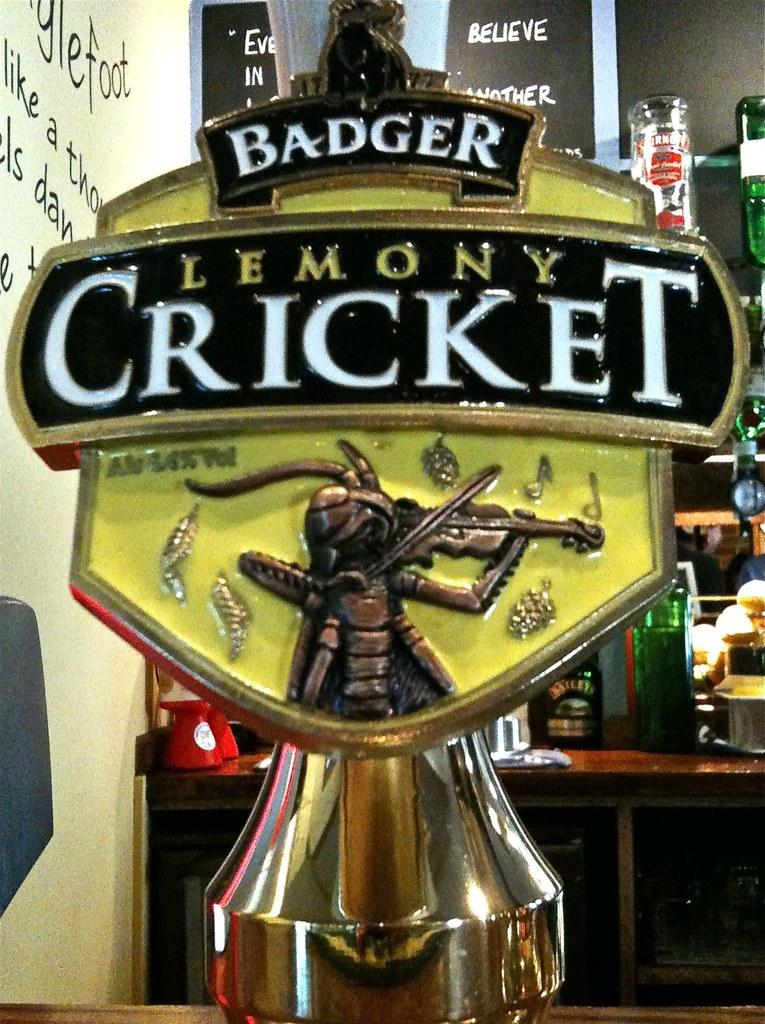<image>
Write a terse but informative summary of the picture. A beer tap for Badger Lemoney Cricket has a fiddling cricket on it. 